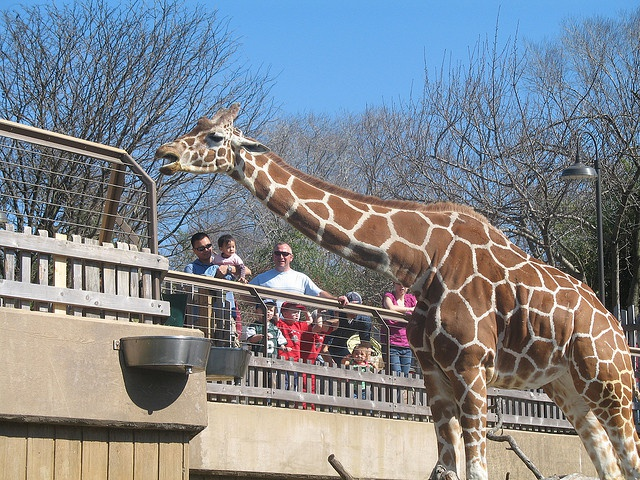Describe the objects in this image and their specific colors. I can see giraffe in lightblue, gray, ivory, and black tones, people in lightblue, gray, violet, black, and maroon tones, people in lightblue, white, gray, and lightpink tones, people in lightblue, black, gray, maroon, and darkgray tones, and people in lightblue, salmon, gray, maroon, and red tones in this image. 